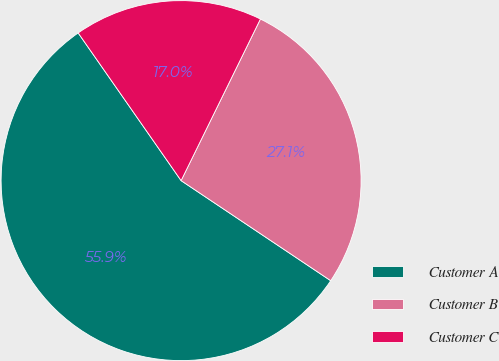Convert chart. <chart><loc_0><loc_0><loc_500><loc_500><pie_chart><fcel>Customer A<fcel>Customer B<fcel>Customer C<nl><fcel>55.93%<fcel>27.12%<fcel>16.95%<nl></chart> 